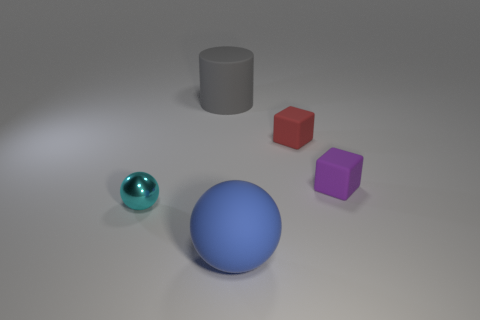There is a large sphere; are there any large matte things to the left of it?
Offer a very short reply. Yes. What number of other small matte objects are the same shape as the small red thing?
Offer a terse response. 1. What color is the large thing that is in front of the big matte object behind the block that is right of the red rubber block?
Ensure brevity in your answer.  Blue. Do the tiny thing that is behind the small purple matte cube and the ball behind the blue rubber object have the same material?
Your answer should be very brief. No. How many things are either objects that are right of the gray matte object or big gray rubber cylinders?
Make the answer very short. 4. How many objects are either small brown blocks or rubber objects on the right side of the red rubber cube?
Give a very brief answer. 1. How many matte blocks are the same size as the red thing?
Give a very brief answer. 1. Is the number of red things behind the big blue ball less than the number of objects that are to the right of the gray cylinder?
Your answer should be compact. Yes. What number of metallic things are tiny purple objects or big brown cylinders?
Offer a very short reply. 0. What is the shape of the red matte thing?
Make the answer very short. Cube. 